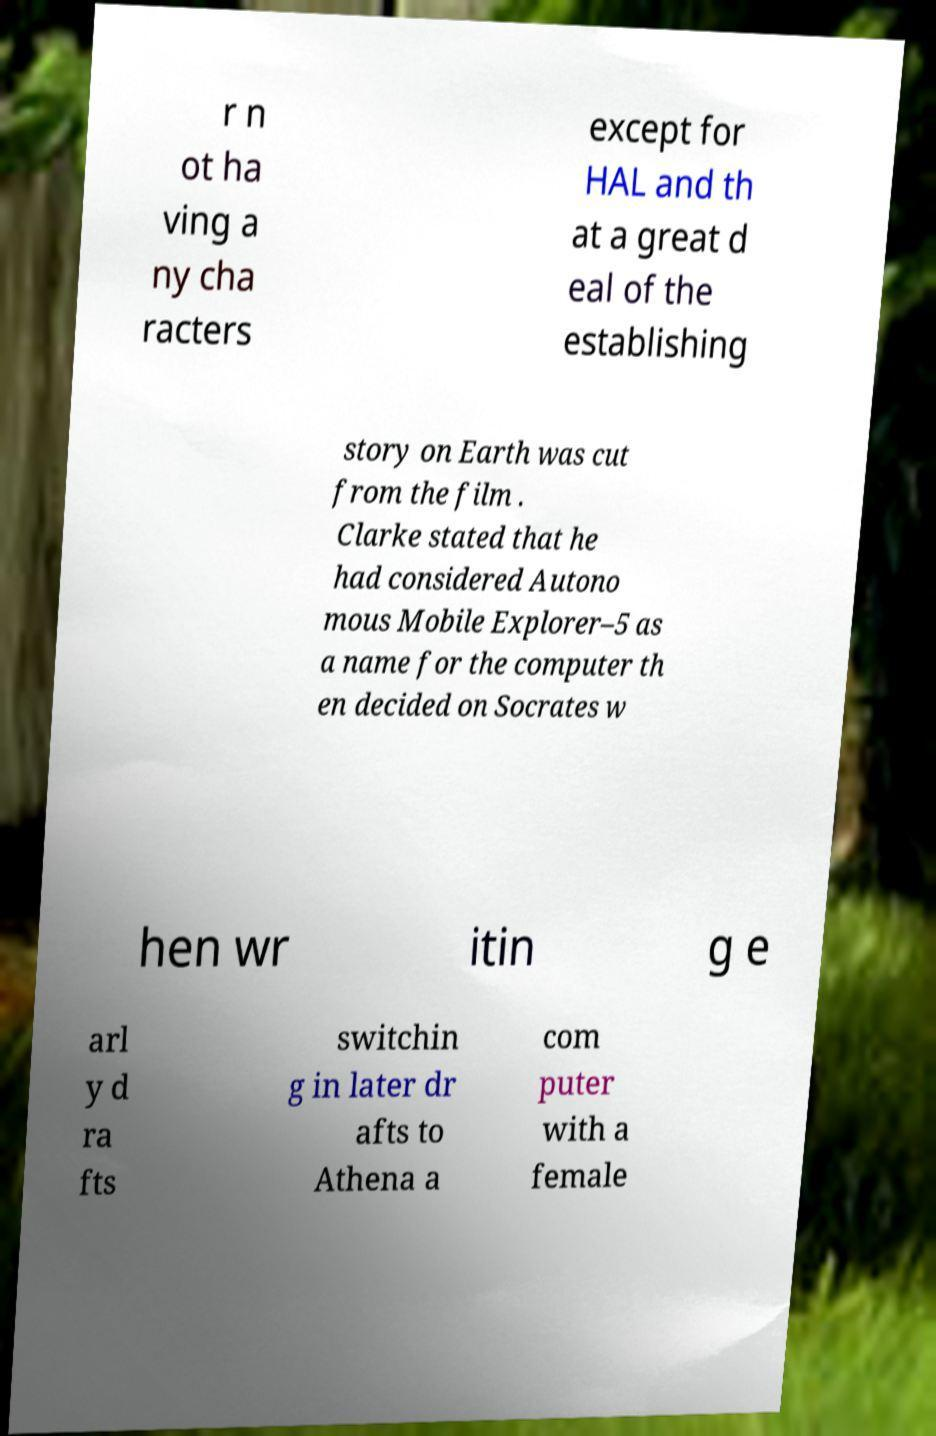For documentation purposes, I need the text within this image transcribed. Could you provide that? r n ot ha ving a ny cha racters except for HAL and th at a great d eal of the establishing story on Earth was cut from the film . Clarke stated that he had considered Autono mous Mobile Explorer–5 as a name for the computer th en decided on Socrates w hen wr itin g e arl y d ra fts switchin g in later dr afts to Athena a com puter with a female 